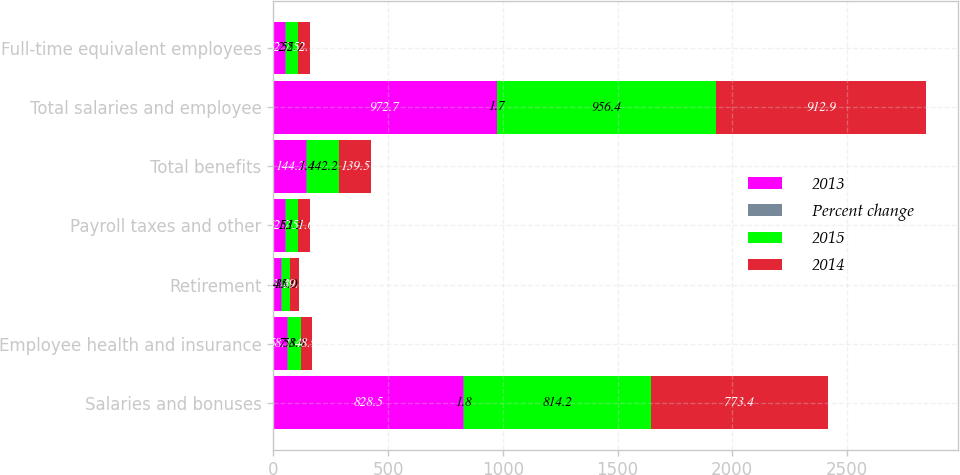Convert chart to OTSL. <chart><loc_0><loc_0><loc_500><loc_500><stacked_bar_chart><ecel><fcel>Salaries and bonuses<fcel>Employee health and insurance<fcel>Retirement<fcel>Payroll taxes and other<fcel>Total benefits<fcel>Total salaries and employee<fcel>Full-time equivalent employees<nl><fcel>2013<fcel>828.5<fcel>58.1<fcel>33.4<fcel>52.7<fcel>144.2<fcel>972.7<fcel>52.7<nl><fcel>Percent change<fcel>1.8<fcel>7.8<fcel>4.6<fcel>1.1<fcel>1.4<fcel>1.7<fcel>2.5<nl><fcel>2015<fcel>814.2<fcel>53.9<fcel>35<fcel>53.3<fcel>142.2<fcel>956.4<fcel>52.7<nl><fcel>2014<fcel>773.4<fcel>48.9<fcel>39<fcel>51.6<fcel>139.5<fcel>912.9<fcel>52.7<nl></chart> 